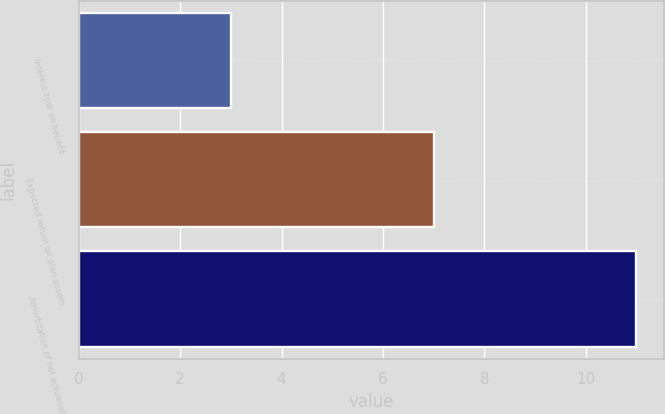<chart> <loc_0><loc_0><loc_500><loc_500><bar_chart><fcel>Interest cost on benefit<fcel>Expected return on plan assets<fcel>Amortization of net actuarial<nl><fcel>3<fcel>7<fcel>11<nl></chart> 